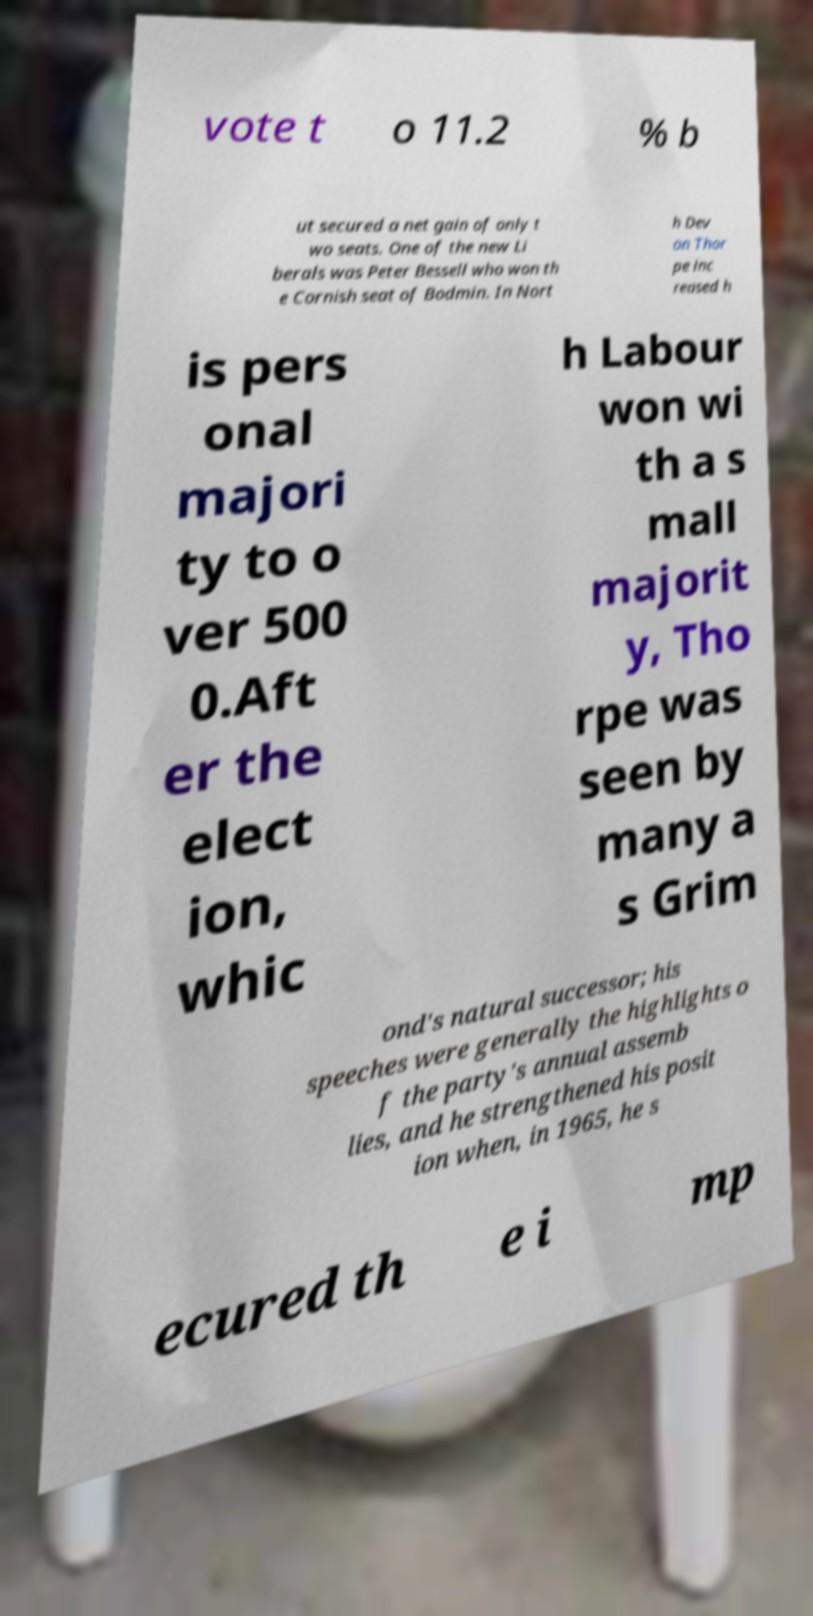I need the written content from this picture converted into text. Can you do that? vote t o 11.2 % b ut secured a net gain of only t wo seats. One of the new Li berals was Peter Bessell who won th e Cornish seat of Bodmin. In Nort h Dev on Thor pe inc reased h is pers onal majori ty to o ver 500 0.Aft er the elect ion, whic h Labour won wi th a s mall majorit y, Tho rpe was seen by many a s Grim ond's natural successor; his speeches were generally the highlights o f the party's annual assemb lies, and he strengthened his posit ion when, in 1965, he s ecured th e i mp 